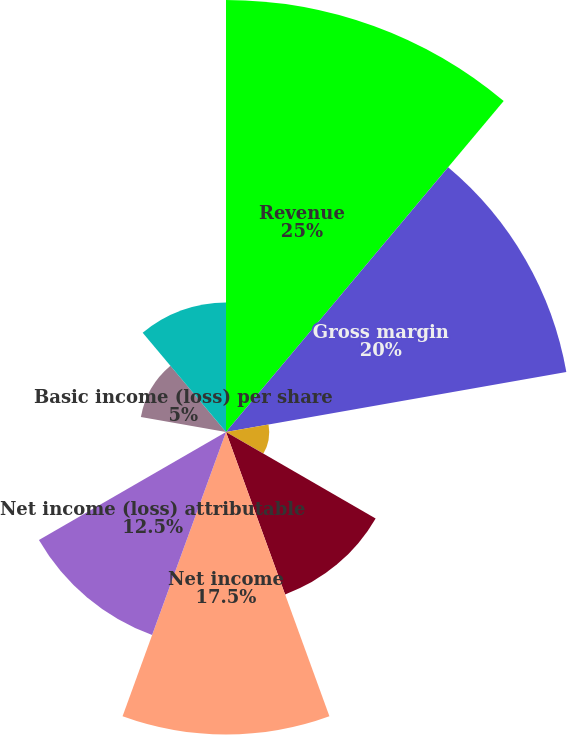Convert chart to OTSL. <chart><loc_0><loc_0><loc_500><loc_500><pie_chart><fcel>Revenue<fcel>Gross margin<fcel>Income from continuing<fcel>Discontinued operations net of<fcel>Net income<fcel>Net income (loss) attributable<fcel>Discontinued operations<fcel>Basic income (loss) per share<fcel>Diluted income (loss) per<nl><fcel>25.0%<fcel>20.0%<fcel>2.5%<fcel>10.0%<fcel>17.5%<fcel>12.5%<fcel>0.0%<fcel>5.0%<fcel>7.5%<nl></chart> 